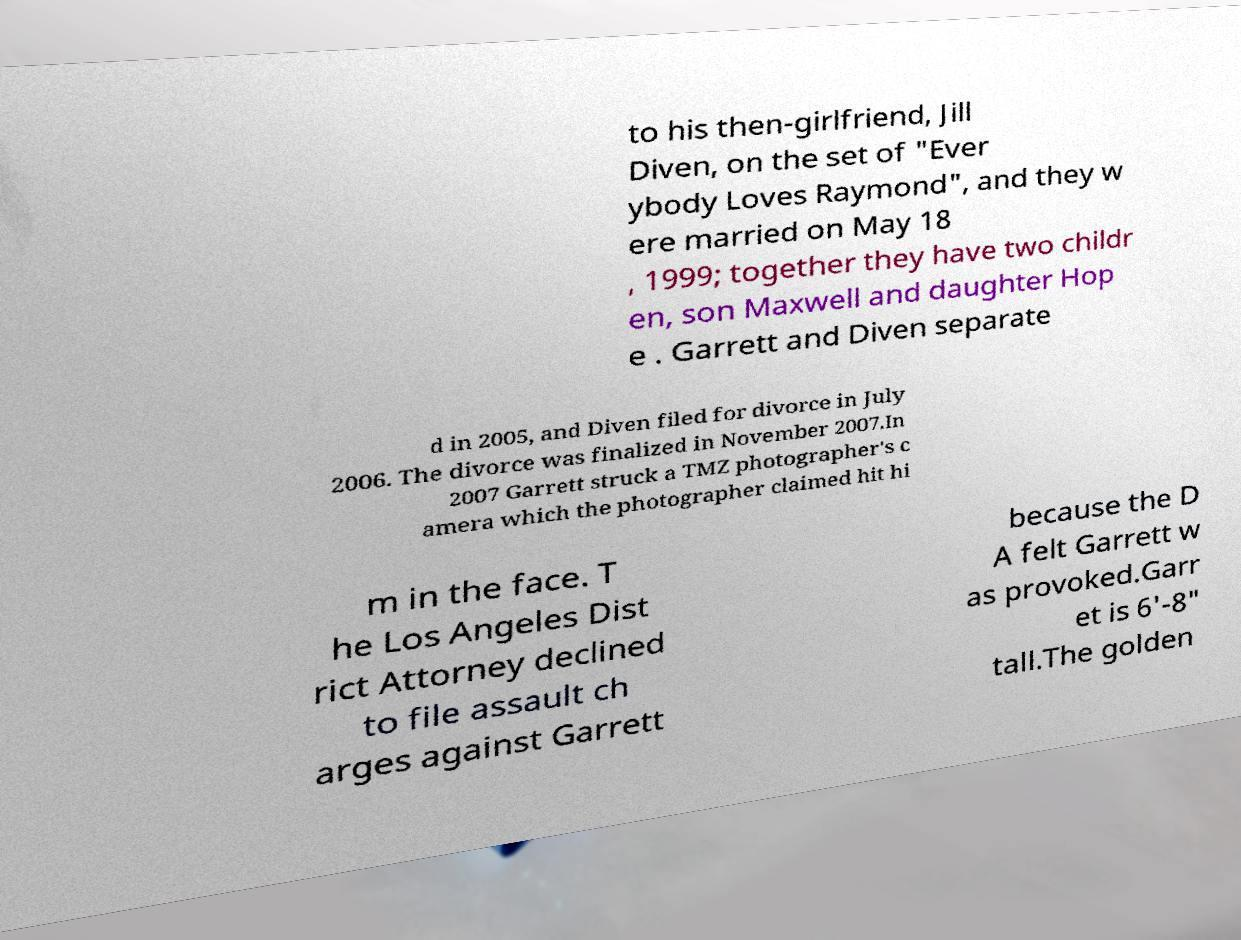Can you accurately transcribe the text from the provided image for me? to his then-girlfriend, Jill Diven, on the set of "Ever ybody Loves Raymond", and they w ere married on May 18 , 1999; together they have two childr en, son Maxwell and daughter Hop e . Garrett and Diven separate d in 2005, and Diven filed for divorce in July 2006. The divorce was finalized in November 2007.In 2007 Garrett struck a TMZ photographer's c amera which the photographer claimed hit hi m in the face. T he Los Angeles Dist rict Attorney declined to file assault ch arges against Garrett because the D A felt Garrett w as provoked.Garr et is 6'-8" tall.The golden 